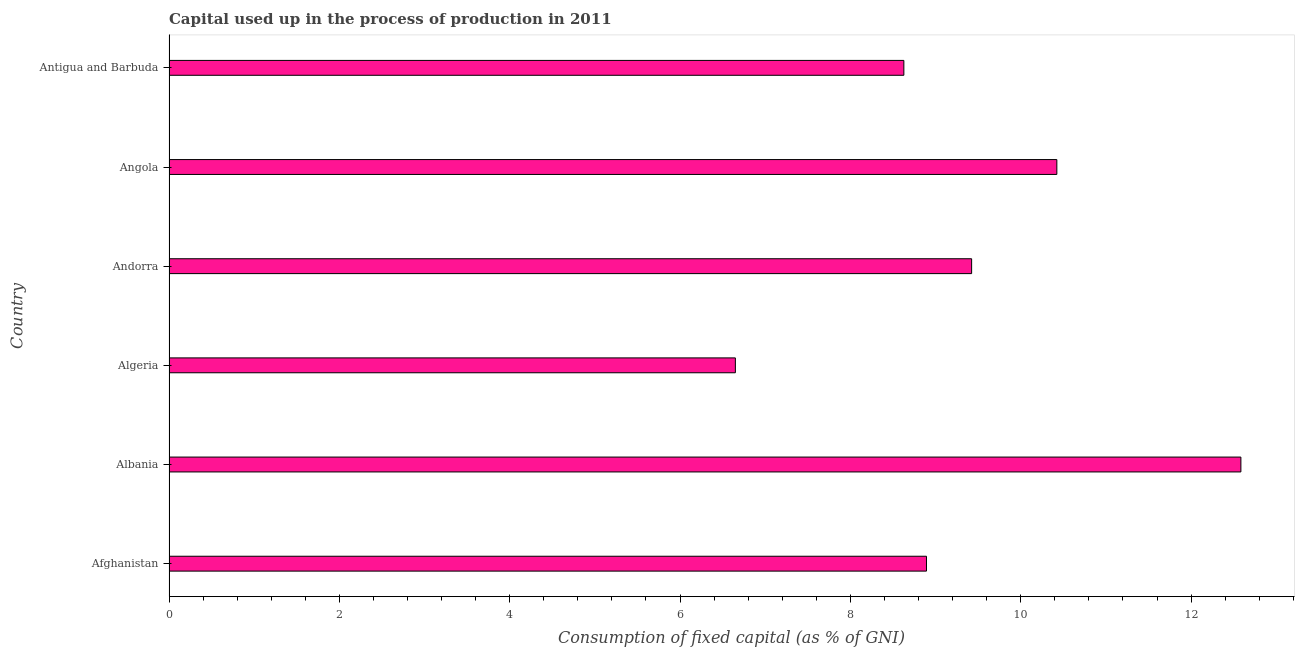Does the graph contain any zero values?
Make the answer very short. No. What is the title of the graph?
Keep it short and to the point. Capital used up in the process of production in 2011. What is the label or title of the X-axis?
Provide a succinct answer. Consumption of fixed capital (as % of GNI). What is the consumption of fixed capital in Antigua and Barbuda?
Make the answer very short. 8.63. Across all countries, what is the maximum consumption of fixed capital?
Your answer should be compact. 12.58. Across all countries, what is the minimum consumption of fixed capital?
Offer a very short reply. 6.65. In which country was the consumption of fixed capital maximum?
Ensure brevity in your answer.  Albania. In which country was the consumption of fixed capital minimum?
Make the answer very short. Algeria. What is the sum of the consumption of fixed capital?
Keep it short and to the point. 56.6. What is the difference between the consumption of fixed capital in Afghanistan and Antigua and Barbuda?
Provide a succinct answer. 0.27. What is the average consumption of fixed capital per country?
Ensure brevity in your answer.  9.43. What is the median consumption of fixed capital?
Offer a very short reply. 9.16. In how many countries, is the consumption of fixed capital greater than 8.4 %?
Keep it short and to the point. 5. What is the ratio of the consumption of fixed capital in Afghanistan to that in Antigua and Barbuda?
Your answer should be very brief. 1.03. Is the consumption of fixed capital in Afghanistan less than that in Angola?
Your answer should be compact. Yes. What is the difference between the highest and the second highest consumption of fixed capital?
Provide a succinct answer. 2.16. Is the sum of the consumption of fixed capital in Afghanistan and Algeria greater than the maximum consumption of fixed capital across all countries?
Keep it short and to the point. Yes. What is the difference between the highest and the lowest consumption of fixed capital?
Your response must be concise. 5.93. In how many countries, is the consumption of fixed capital greater than the average consumption of fixed capital taken over all countries?
Your answer should be very brief. 2. Are the values on the major ticks of X-axis written in scientific E-notation?
Offer a terse response. No. What is the Consumption of fixed capital (as % of GNI) of Afghanistan?
Your response must be concise. 8.89. What is the Consumption of fixed capital (as % of GNI) in Albania?
Make the answer very short. 12.58. What is the Consumption of fixed capital (as % of GNI) in Algeria?
Keep it short and to the point. 6.65. What is the Consumption of fixed capital (as % of GNI) in Andorra?
Your answer should be compact. 9.42. What is the Consumption of fixed capital (as % of GNI) in Angola?
Keep it short and to the point. 10.42. What is the Consumption of fixed capital (as % of GNI) in Antigua and Barbuda?
Offer a very short reply. 8.63. What is the difference between the Consumption of fixed capital (as % of GNI) in Afghanistan and Albania?
Your response must be concise. -3.69. What is the difference between the Consumption of fixed capital (as % of GNI) in Afghanistan and Algeria?
Ensure brevity in your answer.  2.24. What is the difference between the Consumption of fixed capital (as % of GNI) in Afghanistan and Andorra?
Your answer should be compact. -0.53. What is the difference between the Consumption of fixed capital (as % of GNI) in Afghanistan and Angola?
Your answer should be compact. -1.53. What is the difference between the Consumption of fixed capital (as % of GNI) in Afghanistan and Antigua and Barbuda?
Your response must be concise. 0.27. What is the difference between the Consumption of fixed capital (as % of GNI) in Albania and Algeria?
Offer a very short reply. 5.93. What is the difference between the Consumption of fixed capital (as % of GNI) in Albania and Andorra?
Your answer should be compact. 3.16. What is the difference between the Consumption of fixed capital (as % of GNI) in Albania and Angola?
Your answer should be compact. 2.16. What is the difference between the Consumption of fixed capital (as % of GNI) in Albania and Antigua and Barbuda?
Your answer should be very brief. 3.96. What is the difference between the Consumption of fixed capital (as % of GNI) in Algeria and Andorra?
Your answer should be very brief. -2.77. What is the difference between the Consumption of fixed capital (as % of GNI) in Algeria and Angola?
Ensure brevity in your answer.  -3.77. What is the difference between the Consumption of fixed capital (as % of GNI) in Algeria and Antigua and Barbuda?
Offer a very short reply. -1.98. What is the difference between the Consumption of fixed capital (as % of GNI) in Andorra and Angola?
Give a very brief answer. -1. What is the difference between the Consumption of fixed capital (as % of GNI) in Andorra and Antigua and Barbuda?
Your response must be concise. 0.8. What is the difference between the Consumption of fixed capital (as % of GNI) in Angola and Antigua and Barbuda?
Offer a terse response. 1.8. What is the ratio of the Consumption of fixed capital (as % of GNI) in Afghanistan to that in Albania?
Offer a terse response. 0.71. What is the ratio of the Consumption of fixed capital (as % of GNI) in Afghanistan to that in Algeria?
Provide a short and direct response. 1.34. What is the ratio of the Consumption of fixed capital (as % of GNI) in Afghanistan to that in Andorra?
Provide a succinct answer. 0.94. What is the ratio of the Consumption of fixed capital (as % of GNI) in Afghanistan to that in Angola?
Offer a terse response. 0.85. What is the ratio of the Consumption of fixed capital (as % of GNI) in Afghanistan to that in Antigua and Barbuda?
Ensure brevity in your answer.  1.03. What is the ratio of the Consumption of fixed capital (as % of GNI) in Albania to that in Algeria?
Your answer should be compact. 1.89. What is the ratio of the Consumption of fixed capital (as % of GNI) in Albania to that in Andorra?
Ensure brevity in your answer.  1.33. What is the ratio of the Consumption of fixed capital (as % of GNI) in Albania to that in Angola?
Offer a terse response. 1.21. What is the ratio of the Consumption of fixed capital (as % of GNI) in Albania to that in Antigua and Barbuda?
Your answer should be very brief. 1.46. What is the ratio of the Consumption of fixed capital (as % of GNI) in Algeria to that in Andorra?
Your response must be concise. 0.71. What is the ratio of the Consumption of fixed capital (as % of GNI) in Algeria to that in Angola?
Your response must be concise. 0.64. What is the ratio of the Consumption of fixed capital (as % of GNI) in Algeria to that in Antigua and Barbuda?
Ensure brevity in your answer.  0.77. What is the ratio of the Consumption of fixed capital (as % of GNI) in Andorra to that in Angola?
Keep it short and to the point. 0.9. What is the ratio of the Consumption of fixed capital (as % of GNI) in Andorra to that in Antigua and Barbuda?
Ensure brevity in your answer.  1.09. What is the ratio of the Consumption of fixed capital (as % of GNI) in Angola to that in Antigua and Barbuda?
Provide a short and direct response. 1.21. 